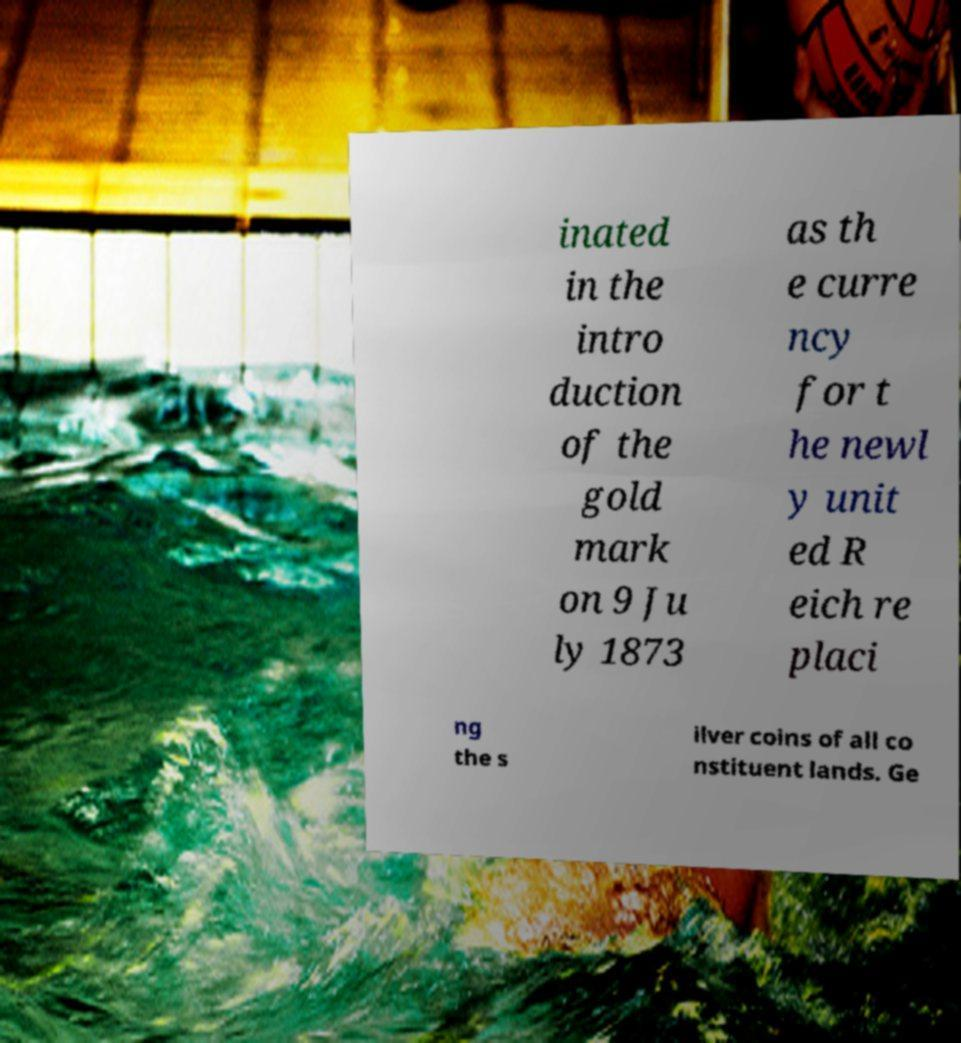I need the written content from this picture converted into text. Can you do that? inated in the intro duction of the gold mark on 9 Ju ly 1873 as th e curre ncy for t he newl y unit ed R eich re placi ng the s ilver coins of all co nstituent lands. Ge 